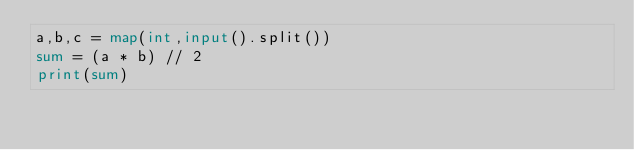<code> <loc_0><loc_0><loc_500><loc_500><_Python_>a,b,c = map(int,input().split())
sum = (a * b) // 2
print(sum)
</code> 